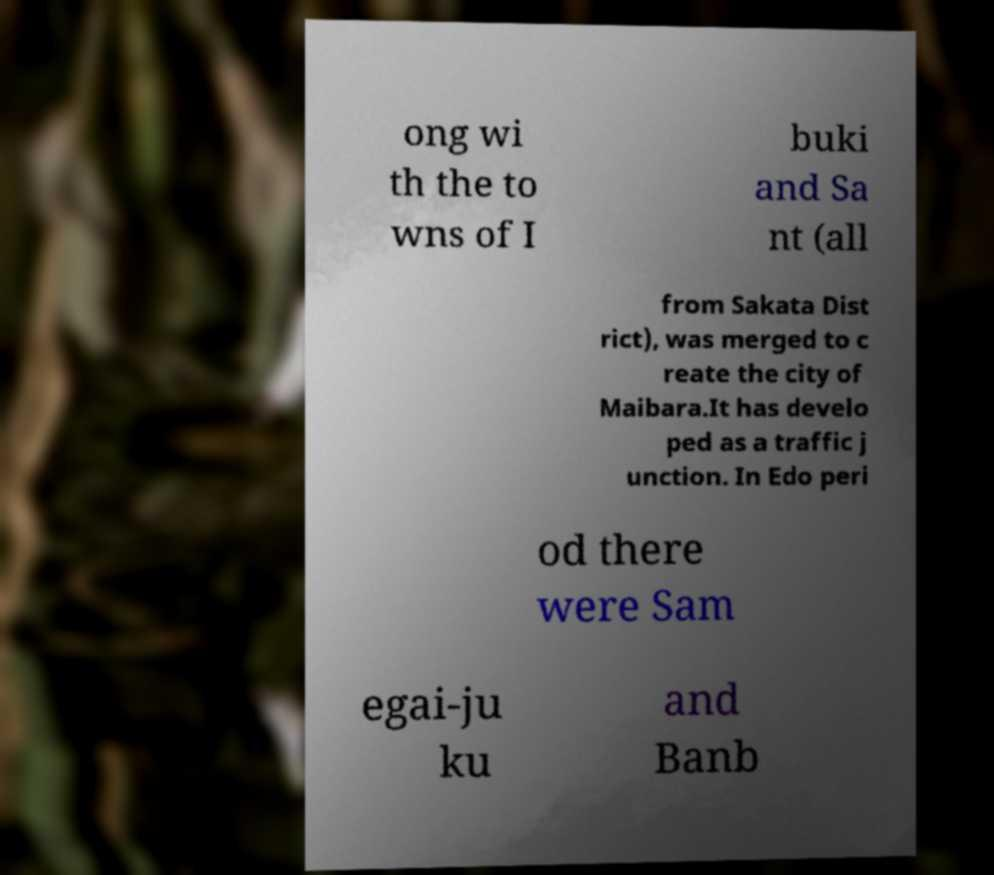Could you assist in decoding the text presented in this image and type it out clearly? ong wi th the to wns of I buki and Sa nt (all from Sakata Dist rict), was merged to c reate the city of Maibara.It has develo ped as a traffic j unction. In Edo peri od there were Sam egai-ju ku and Banb 